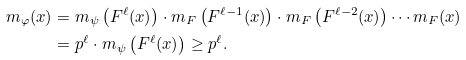Convert formula to latex. <formula><loc_0><loc_0><loc_500><loc_500>m _ { \varphi } ( x ) & = m _ { \psi } \left ( F ^ { \ell } ( x ) \right ) \cdot m _ { F } \left ( F ^ { \ell - 1 } ( x ) \right ) \cdot m _ { F } \left ( F ^ { \ell - 2 } ( x ) \right ) \cdots m _ { F } ( x ) \\ & = p ^ { \ell } \cdot m _ { \psi } \left ( F ^ { \ell } ( x ) \right ) \geq p ^ { \ell } .</formula> 